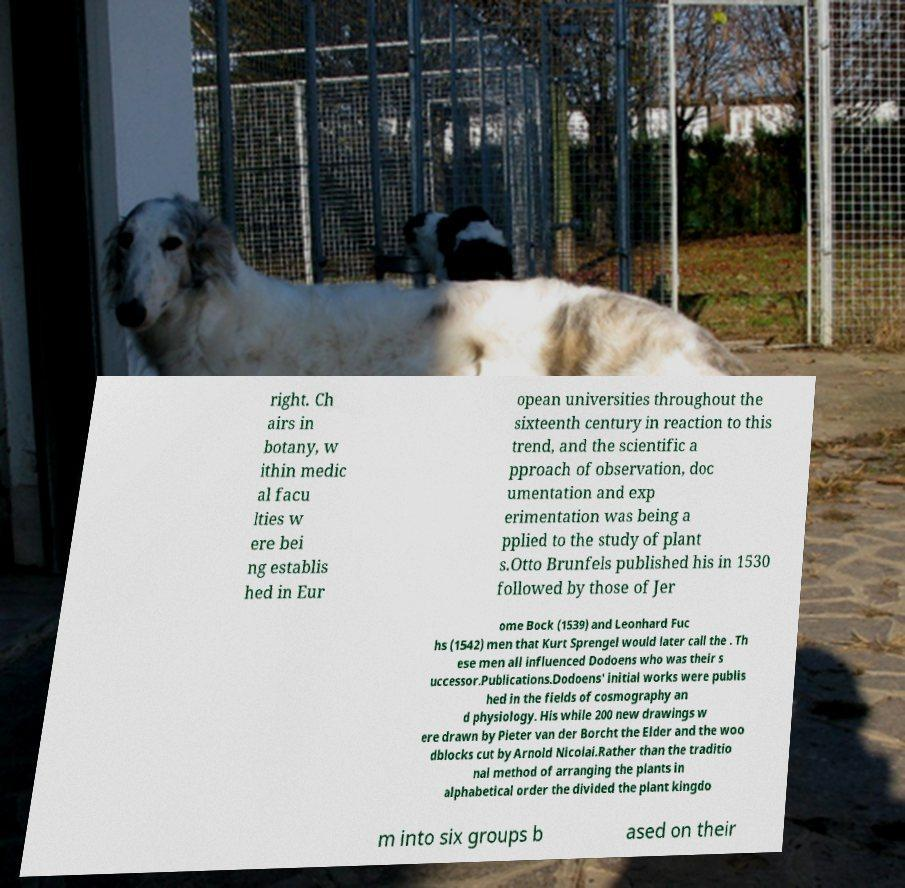There's text embedded in this image that I need extracted. Can you transcribe it verbatim? right. Ch airs in botany, w ithin medic al facu lties w ere bei ng establis hed in Eur opean universities throughout the sixteenth century in reaction to this trend, and the scientific a pproach of observation, doc umentation and exp erimentation was being a pplied to the study of plant s.Otto Brunfels published his in 1530 followed by those of Jer ome Bock (1539) and Leonhard Fuc hs (1542) men that Kurt Sprengel would later call the . Th ese men all influenced Dodoens who was their s uccessor.Publications.Dodoens' initial works were publis hed in the fields of cosmography an d physiology. His while 200 new drawings w ere drawn by Pieter van der Borcht the Elder and the woo dblocks cut by Arnold Nicolai.Rather than the traditio nal method of arranging the plants in alphabetical order the divided the plant kingdo m into six groups b ased on their 